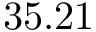<formula> <loc_0><loc_0><loc_500><loc_500>3 5 . 2 1</formula> 